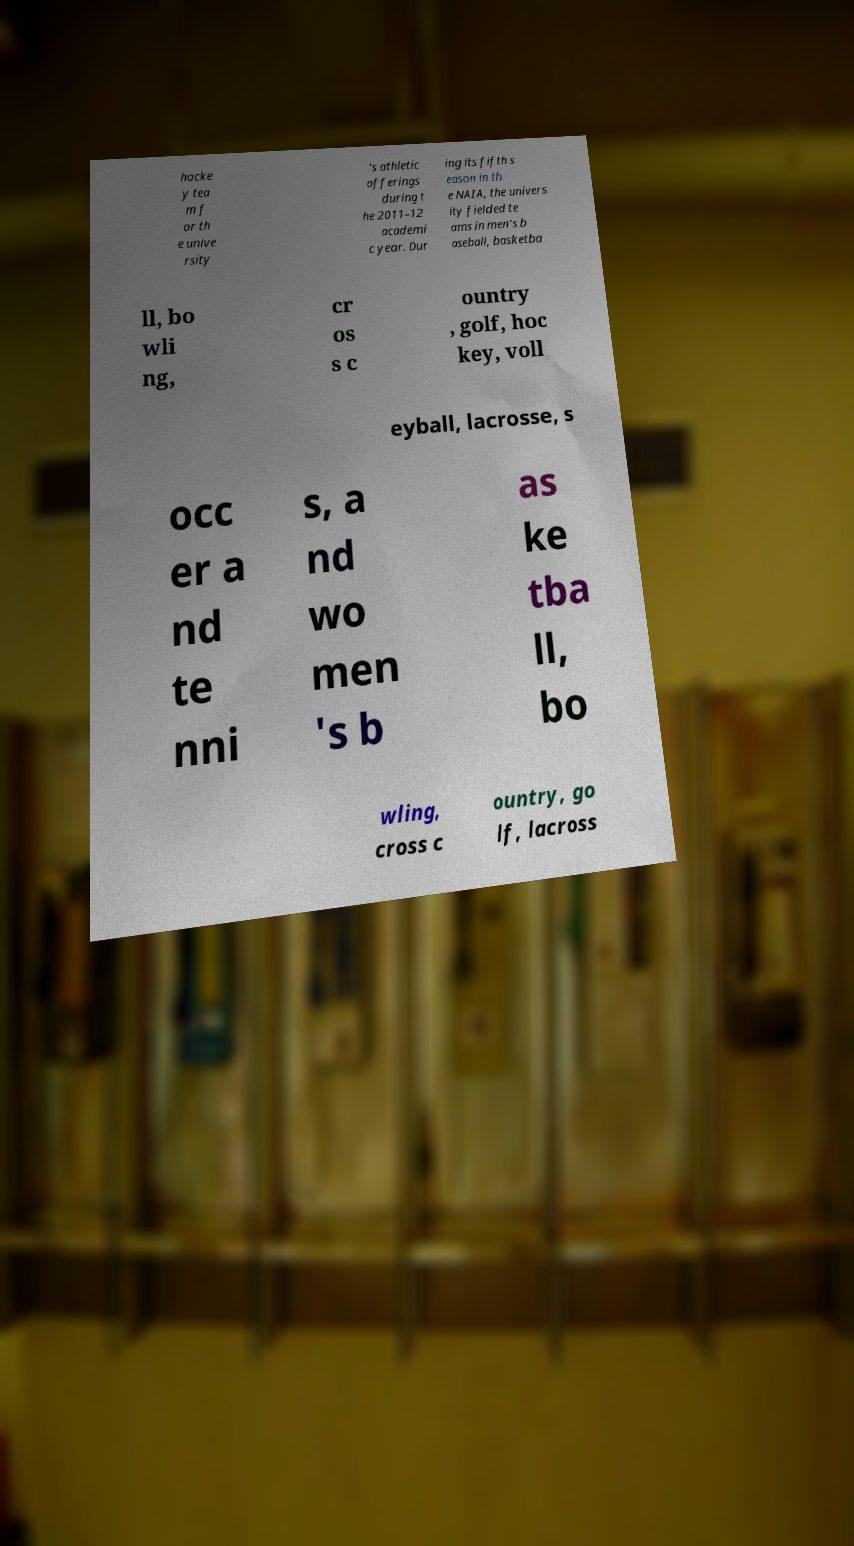There's text embedded in this image that I need extracted. Can you transcribe it verbatim? hocke y tea m f or th e unive rsity 's athletic offerings during t he 2011–12 academi c year. Dur ing its fifth s eason in th e NAIA, the univers ity fielded te ams in men's b aseball, basketba ll, bo wli ng, cr os s c ountry , golf, hoc key, voll eyball, lacrosse, s occ er a nd te nni s, a nd wo men 's b as ke tba ll, bo wling, cross c ountry, go lf, lacross 